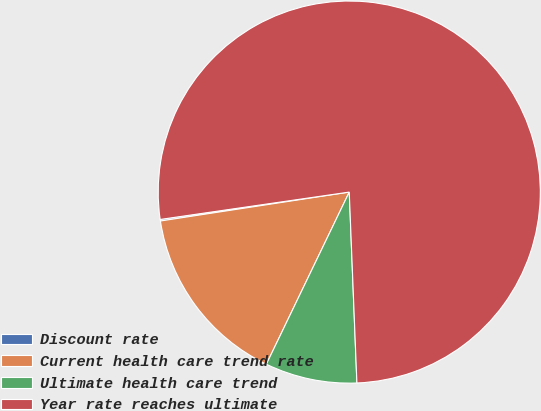Convert chart. <chart><loc_0><loc_0><loc_500><loc_500><pie_chart><fcel>Discount rate<fcel>Current health care trend rate<fcel>Ultimate health care trend<fcel>Year rate reaches ultimate<nl><fcel>0.13%<fcel>15.44%<fcel>7.78%<fcel>76.65%<nl></chart> 